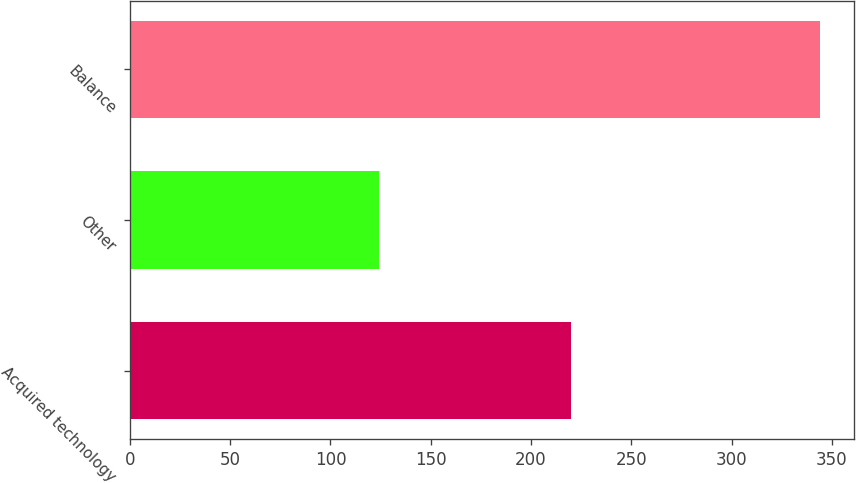<chart> <loc_0><loc_0><loc_500><loc_500><bar_chart><fcel>Acquired technology<fcel>Other<fcel>Balance<nl><fcel>220<fcel>124<fcel>344<nl></chart> 